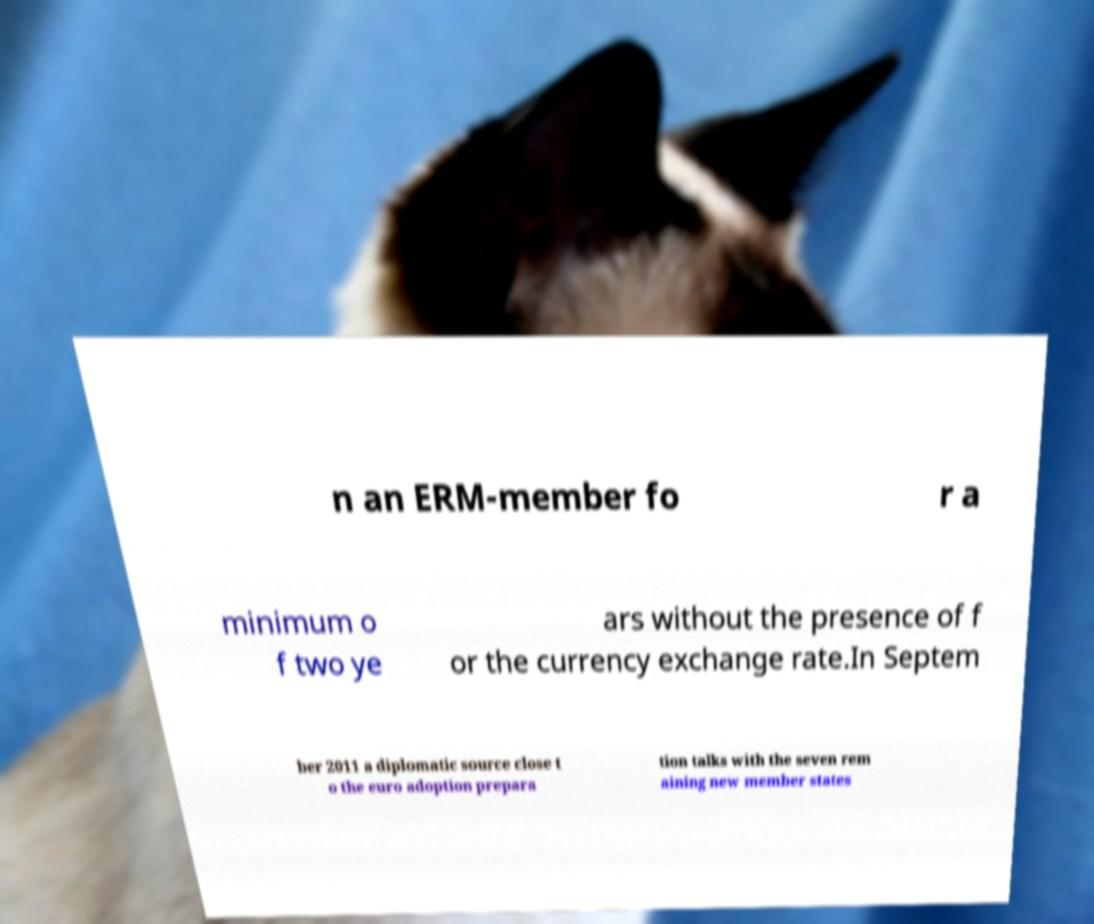There's text embedded in this image that I need extracted. Can you transcribe it verbatim? n an ERM-member fo r a minimum o f two ye ars without the presence of f or the currency exchange rate.In Septem ber 2011 a diplomatic source close t o the euro adoption prepara tion talks with the seven rem aining new member states 